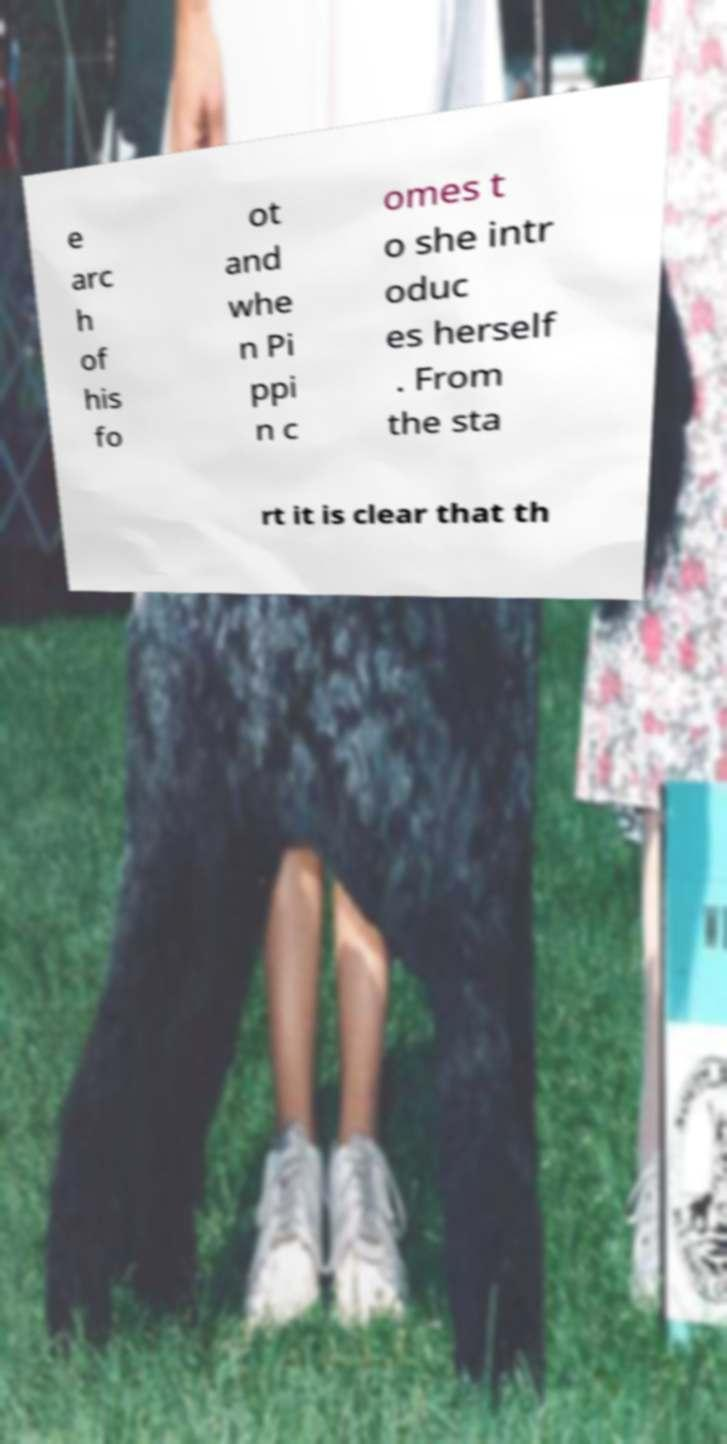For documentation purposes, I need the text within this image transcribed. Could you provide that? e arc h of his fo ot and whe n Pi ppi n c omes t o she intr oduc es herself . From the sta rt it is clear that th 